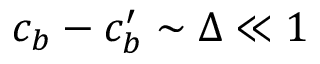<formula> <loc_0><loc_0><loc_500><loc_500>c _ { b } - c _ { b } ^ { \prime } \sim \Delta \ll 1</formula> 